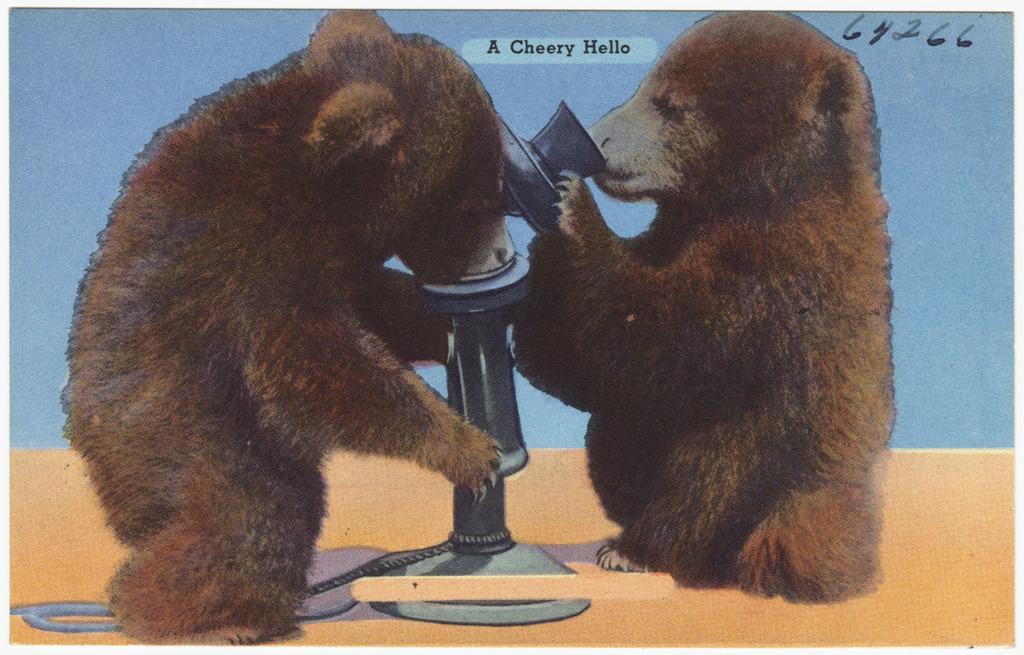Can you describe this image briefly? In this picture I see couple of bears and it looks like a water fountain with a rope on the bottom and i can see text at the top of the picture and a number on the top right corner. 